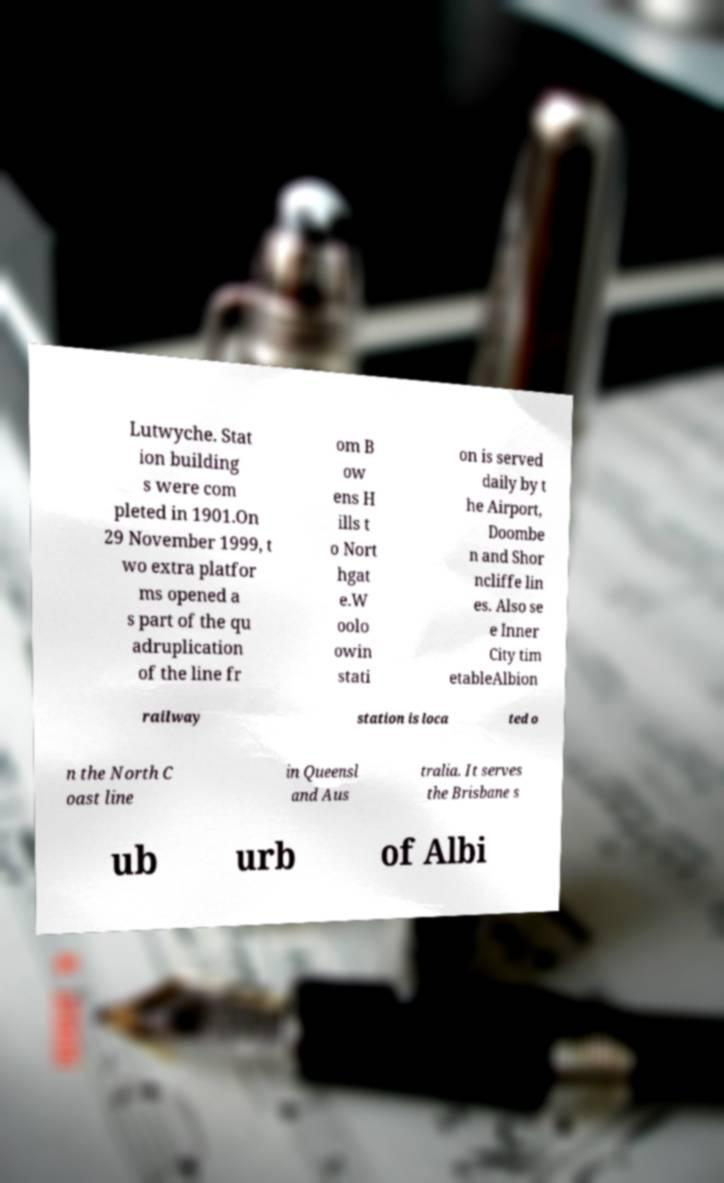Please identify and transcribe the text found in this image. Lutwyche. Stat ion building s were com pleted in 1901.On 29 November 1999, t wo extra platfor ms opened a s part of the qu adruplication of the line fr om B ow ens H ills t o Nort hgat e.W oolo owin stati on is served daily by t he Airport, Doombe n and Shor ncliffe lin es. Also se e Inner City tim etableAlbion railway station is loca ted o n the North C oast line in Queensl and Aus tralia. It serves the Brisbane s ub urb of Albi 